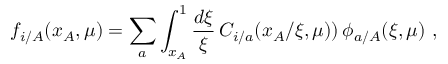<formula> <loc_0><loc_0><loc_500><loc_500>f _ { i / A } ( x _ { A } , \mu ) = \sum _ { a } \int _ { x _ { A } } ^ { 1 } \frac { d \xi } { \xi } \, C _ { i / a } ( x _ { A } / \xi , \mu ) ) \, \phi _ { a / A } ( \xi , \mu ) \, ,</formula> 